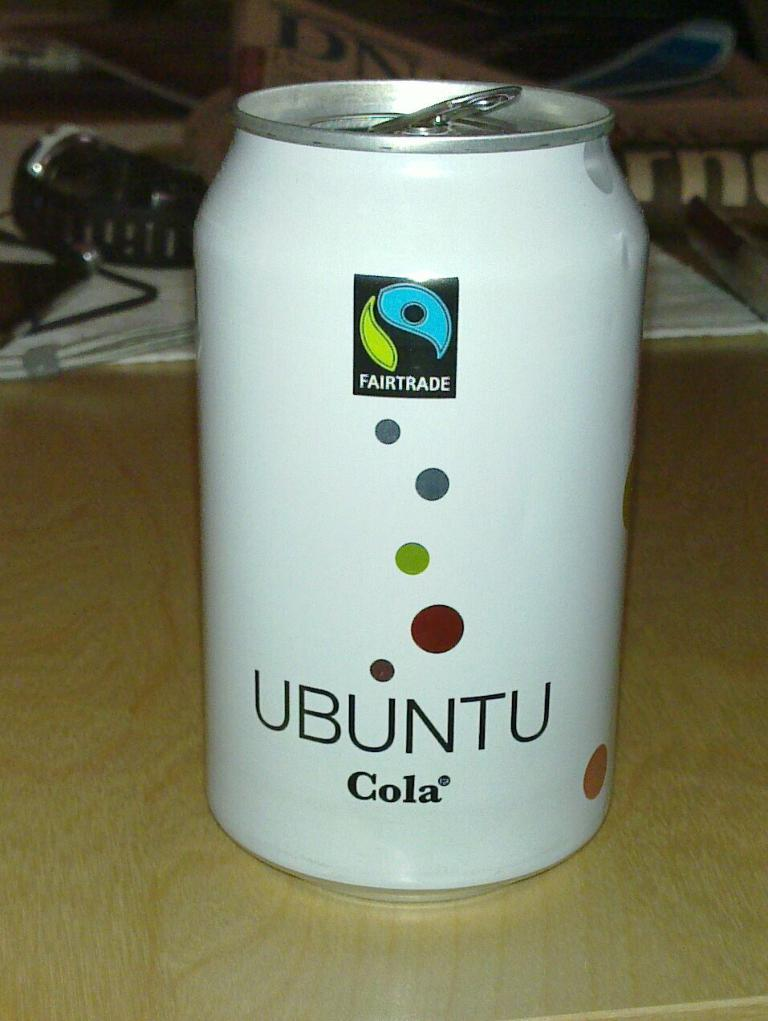<image>
Provide a brief description of the given image. A white tin can that says ubuntu cola on the botom of the center of the can. 